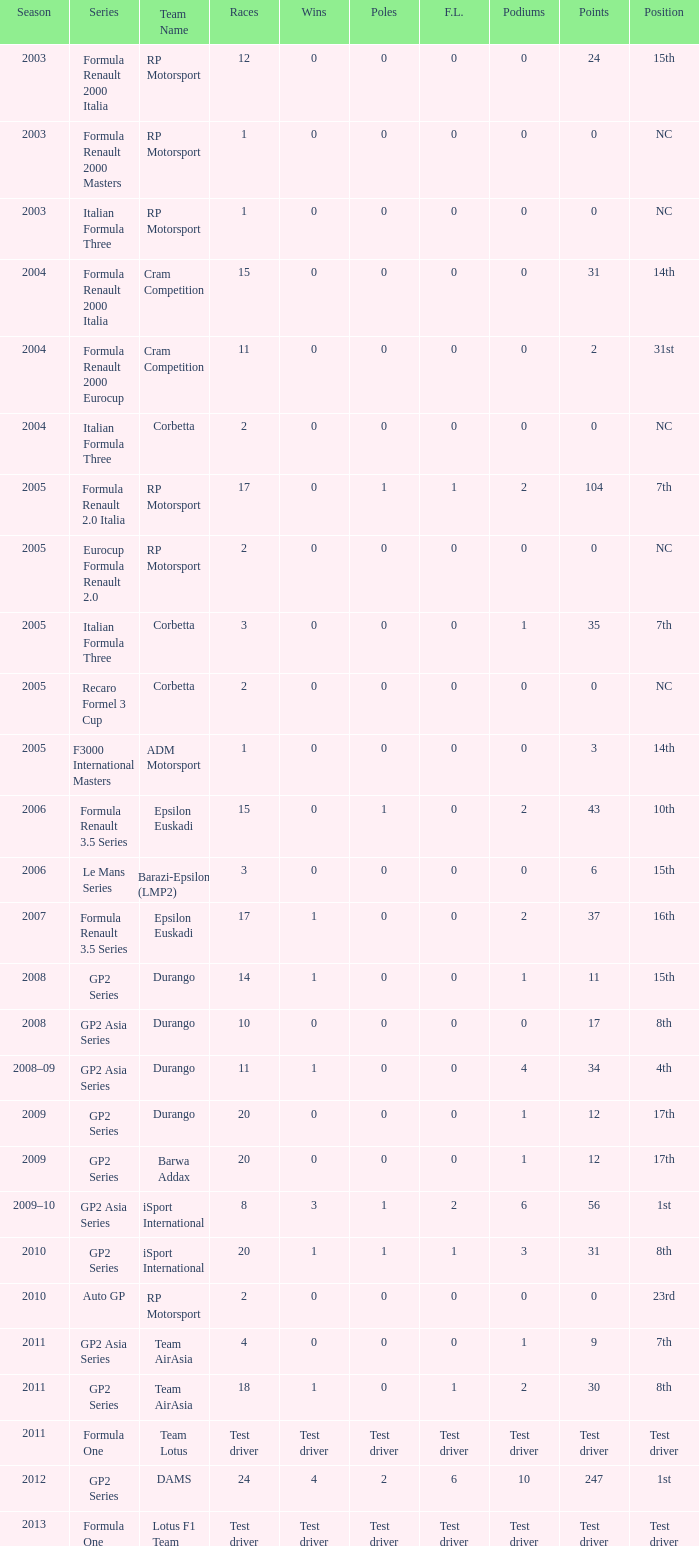Would you be able to parse every entry in this table? {'header': ['Season', 'Series', 'Team Name', 'Races', 'Wins', 'Poles', 'F.L.', 'Podiums', 'Points', 'Position'], 'rows': [['2003', 'Formula Renault 2000 Italia', 'RP Motorsport', '12', '0', '0', '0', '0', '24', '15th'], ['2003', 'Formula Renault 2000 Masters', 'RP Motorsport', '1', '0', '0', '0', '0', '0', 'NC'], ['2003', 'Italian Formula Three', 'RP Motorsport', '1', '0', '0', '0', '0', '0', 'NC'], ['2004', 'Formula Renault 2000 Italia', 'Cram Competition', '15', '0', '0', '0', '0', '31', '14th'], ['2004', 'Formula Renault 2000 Eurocup', 'Cram Competition', '11', '0', '0', '0', '0', '2', '31st'], ['2004', 'Italian Formula Three', 'Corbetta', '2', '0', '0', '0', '0', '0', 'NC'], ['2005', 'Formula Renault 2.0 Italia', 'RP Motorsport', '17', '0', '1', '1', '2', '104', '7th'], ['2005', 'Eurocup Formula Renault 2.0', 'RP Motorsport', '2', '0', '0', '0', '0', '0', 'NC'], ['2005', 'Italian Formula Three', 'Corbetta', '3', '0', '0', '0', '1', '35', '7th'], ['2005', 'Recaro Formel 3 Cup', 'Corbetta', '2', '0', '0', '0', '0', '0', 'NC'], ['2005', 'F3000 International Masters', 'ADM Motorsport', '1', '0', '0', '0', '0', '3', '14th'], ['2006', 'Formula Renault 3.5 Series', 'Epsilon Euskadi', '15', '0', '1', '0', '2', '43', '10th'], ['2006', 'Le Mans Series', 'Barazi-Epsilon (LMP2)', '3', '0', '0', '0', '0', '6', '15th'], ['2007', 'Formula Renault 3.5 Series', 'Epsilon Euskadi', '17', '1', '0', '0', '2', '37', '16th'], ['2008', 'GP2 Series', 'Durango', '14', '1', '0', '0', '1', '11', '15th'], ['2008', 'GP2 Asia Series', 'Durango', '10', '0', '0', '0', '0', '17', '8th'], ['2008–09', 'GP2 Asia Series', 'Durango', '11', '1', '0', '0', '4', '34', '4th'], ['2009', 'GP2 Series', 'Durango', '20', '0', '0', '0', '1', '12', '17th'], ['2009', 'GP2 Series', 'Barwa Addax', '20', '0', '0', '0', '1', '12', '17th'], ['2009–10', 'GP2 Asia Series', 'iSport International', '8', '3', '1', '2', '6', '56', '1st'], ['2010', 'GP2 Series', 'iSport International', '20', '1', '1', '1', '3', '31', '8th'], ['2010', 'Auto GP', 'RP Motorsport', '2', '0', '0', '0', '0', '0', '23rd'], ['2011', 'GP2 Asia Series', 'Team AirAsia', '4', '0', '0', '0', '1', '9', '7th'], ['2011', 'GP2 Series', 'Team AirAsia', '18', '1', '0', '1', '2', '30', '8th'], ['2011', 'Formula One', 'Team Lotus', 'Test driver', 'Test driver', 'Test driver', 'Test driver', 'Test driver', 'Test driver', 'Test driver'], ['2012', 'GP2 Series', 'DAMS', '24', '4', '2', '6', '10', '247', '1st'], ['2013', 'Formula One', 'Lotus F1 Team', 'Test driver', 'Test driver', 'Test driver', 'Test driver', 'Test driver', 'Test driver', 'Test driver']]} What is the number of poles with 104 points? 1.0. 